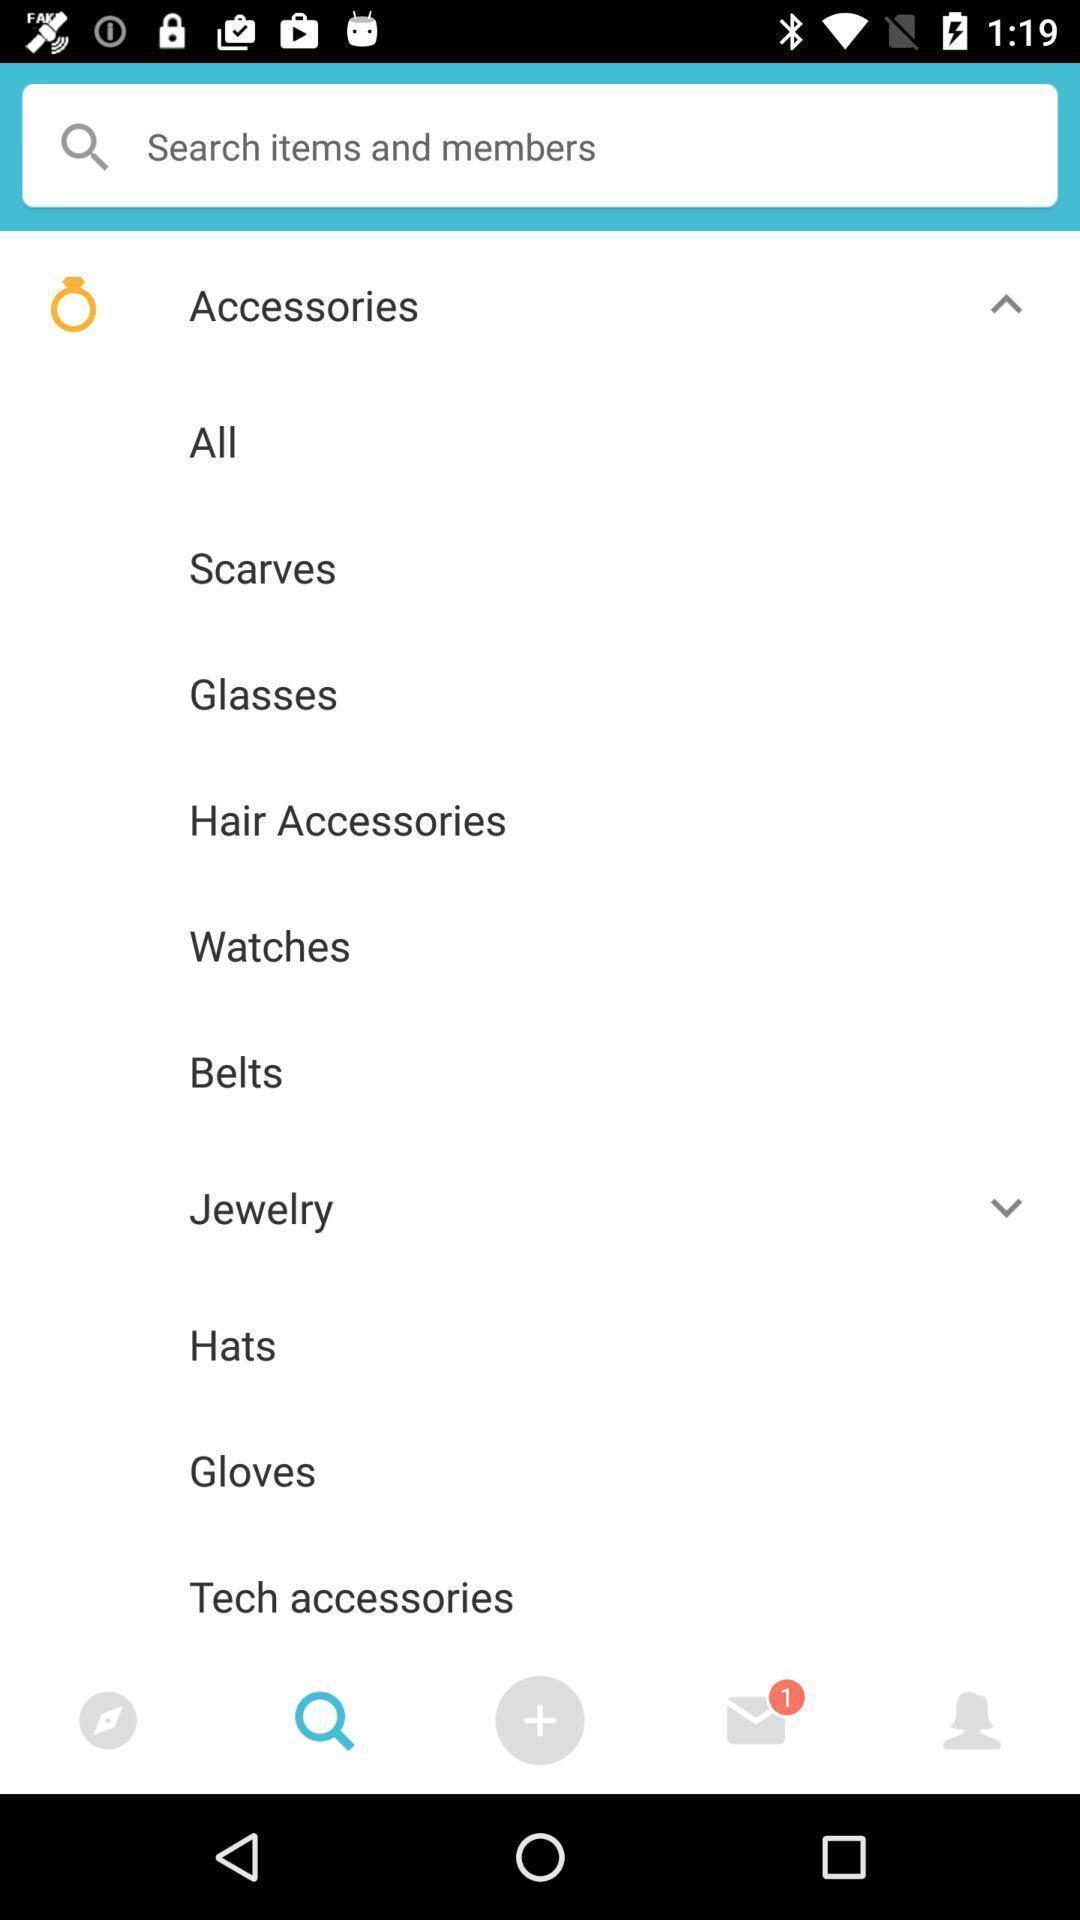Give me a narrative description of this picture. Search page displaying different categories of products in shopping application. 